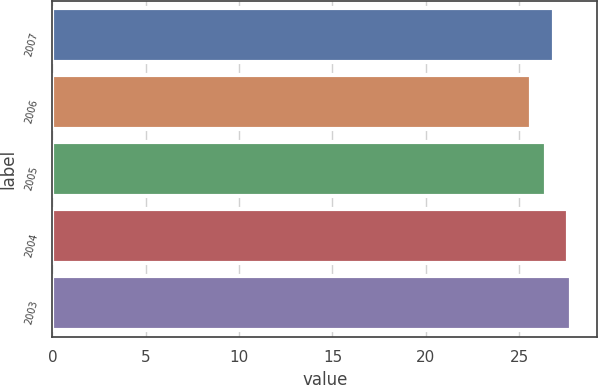Convert chart. <chart><loc_0><loc_0><loc_500><loc_500><bar_chart><fcel>2007<fcel>2006<fcel>2005<fcel>2004<fcel>2003<nl><fcel>26.86<fcel>25.64<fcel>26.42<fcel>27.59<fcel>27.8<nl></chart> 